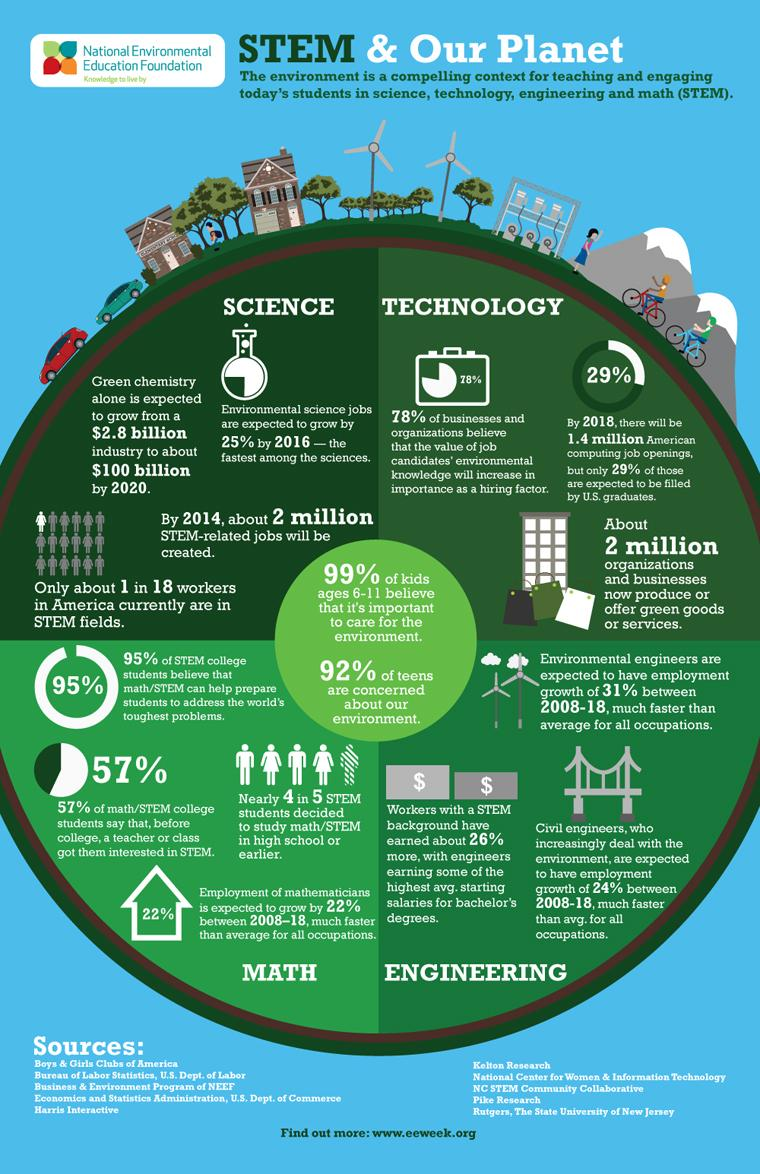Specify some key components in this picture. STEM deals with four streams. According to a recent survey, only 1% of children believe that they do not need to care for the environment. According to statistics, 71% of computing job openings will be held by non-US students. 